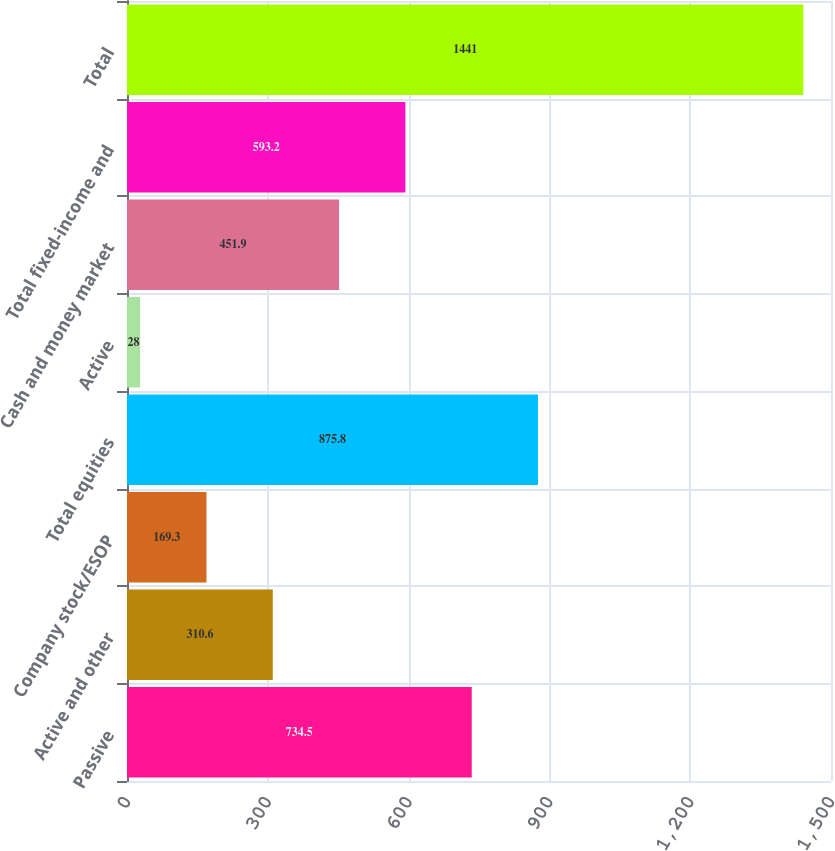<chart> <loc_0><loc_0><loc_500><loc_500><bar_chart><fcel>Passive<fcel>Active and other<fcel>Company stock/ESOP<fcel>Total equities<fcel>Active<fcel>Cash and money market<fcel>Total fixed-income and<fcel>Total<nl><fcel>734.5<fcel>310.6<fcel>169.3<fcel>875.8<fcel>28<fcel>451.9<fcel>593.2<fcel>1441<nl></chart> 